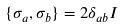Convert formula to latex. <formula><loc_0><loc_0><loc_500><loc_500>\{ \sigma _ { a } , \sigma _ { b } \} = 2 \delta _ { a b } I</formula> 